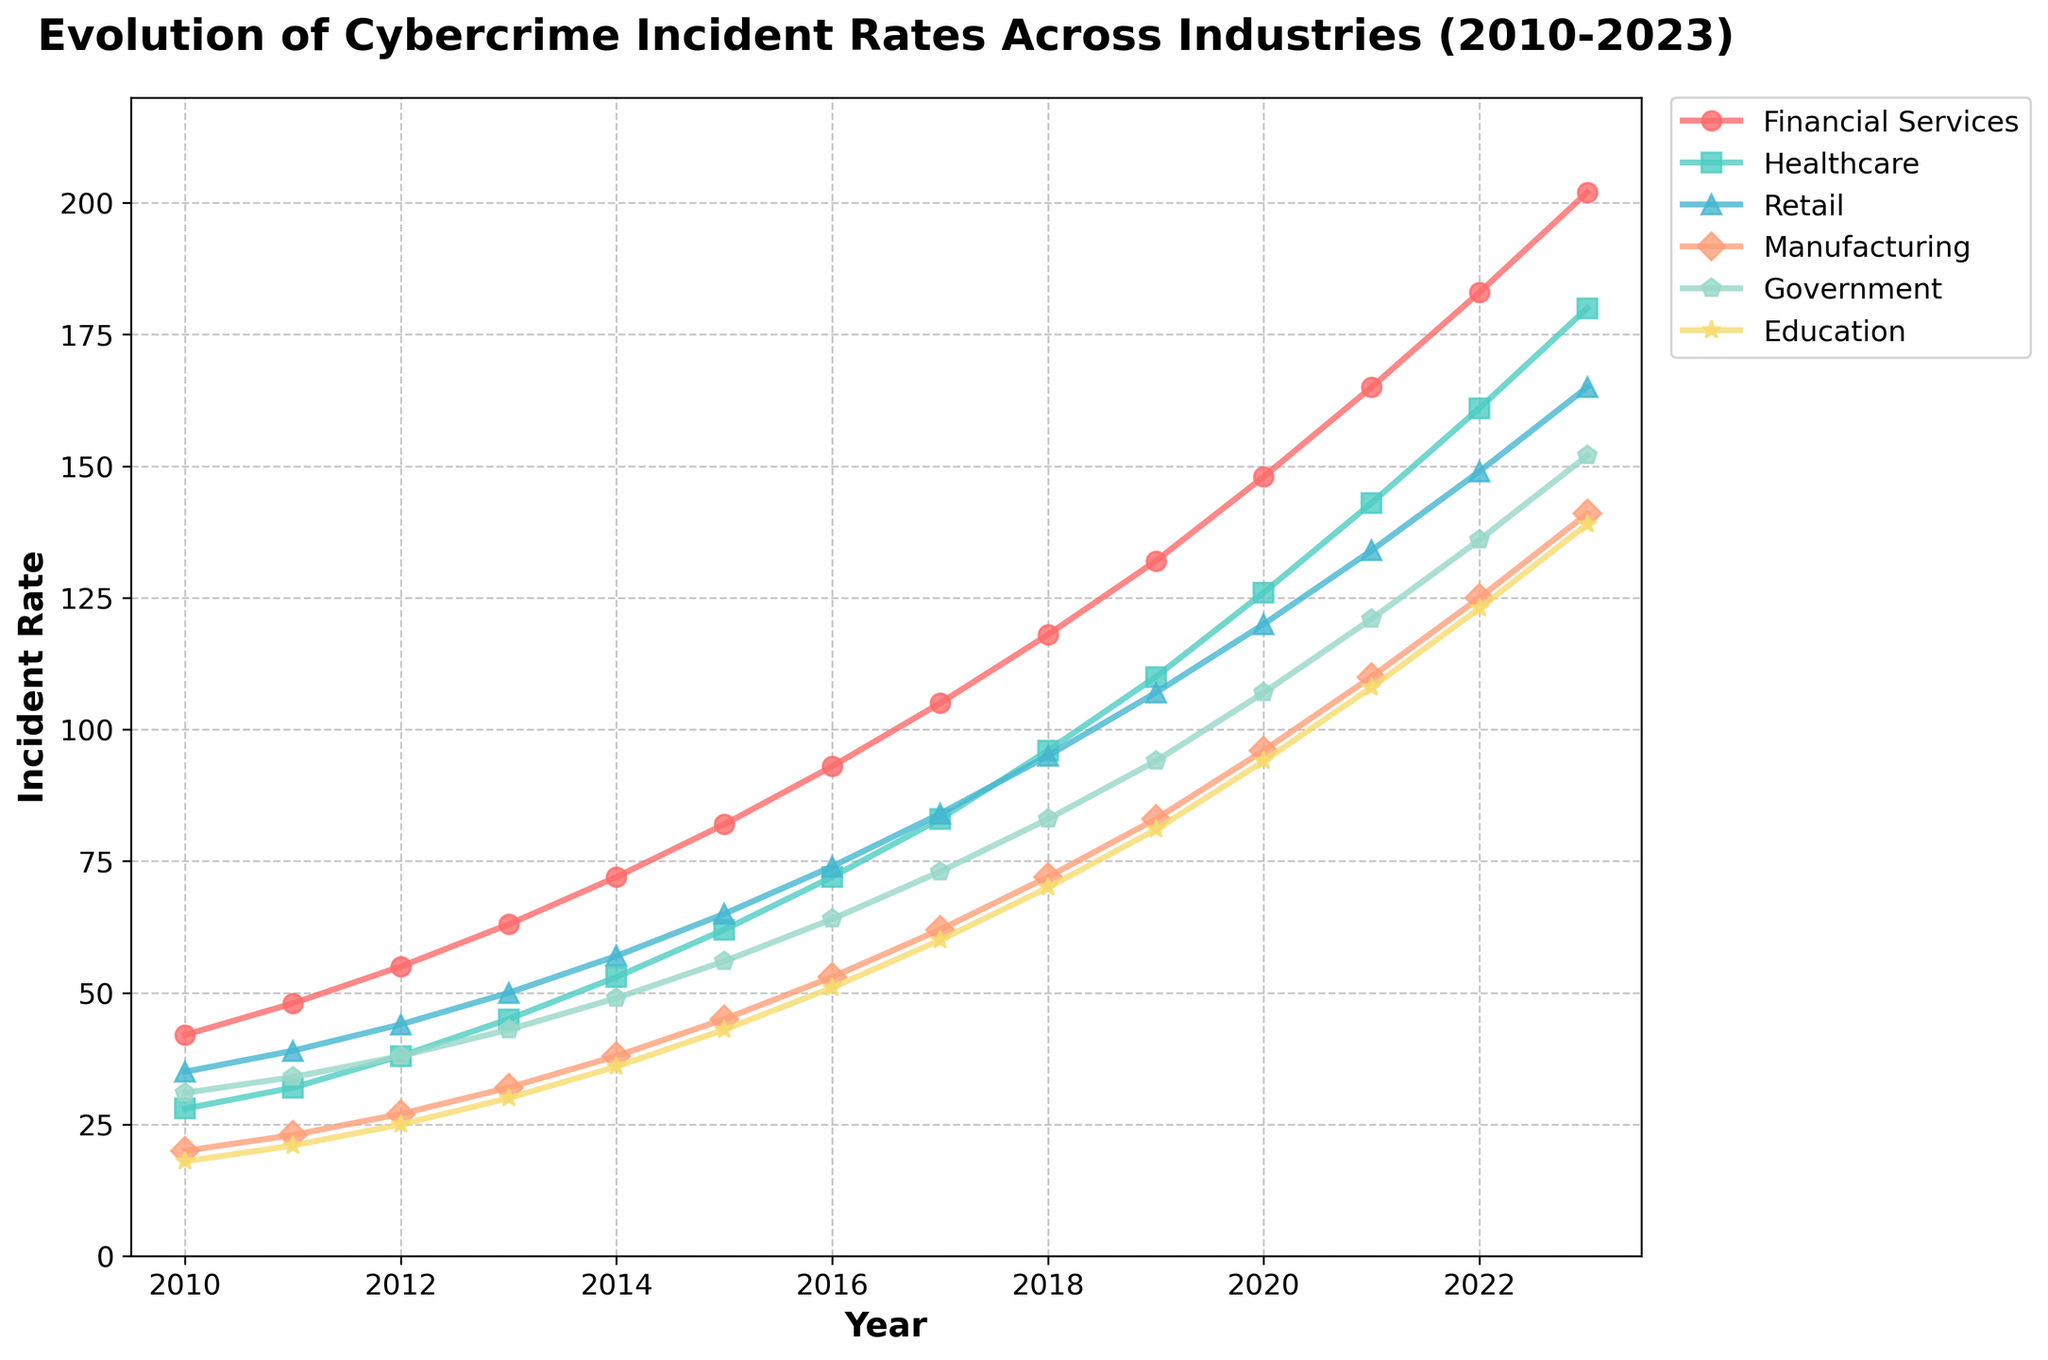What is the incident rate for the Financial Services industry in 2018? Find the point on the line for the Financial Services industry corresponding to the year 2018. The value is 118 according to the chart.
Answer: 118 Which industry had the highest incident rate in 2023? Compare the end points (2023) of all lines representing different industries. The Financial Services line is the highest at 202 incidents.
Answer: Financial Services Between which years did the Healthcare industry see the highest increase in incident rates? Examine the slope of the line for the Healthcare industry and identify the years with the steepest increase. From 2016 to 2017, it increased from 72 to 83, which is the highest yearly increase of 11.
Answer: 2016-2017 How did the incident rates for the Government sector change from 2011 to 2013? Look at the data points for the Government sector in 2011 and 2013, which are 34 and 43 respectively. The change is 43 - 34, an increase of 9.
Answer: Increased by 9 On average, what was the incident rate for the Retail industry from 2010 to 2023? Sum the incident rates for Retail across all years and divide by the number of years. Total is (35 + 39 + 44 + 50 + 57 + 65 + 74 + 84 + 95 + 107 + 120 + 134 + 149 + 165) = 1263. The number of years is 14, so the average is 1263 / 14.
Answer: 90.21 Which industry had a greater incident rate increase from 2010 to 2023: Education or Manufacturing? Calculate the differences for both industries. Education increased from 18 to 139, a change of 121. Manufacturing increased from 20 to 141, a change of 121.
Answer: Both increased equally What is the trend of the incident rates in the Healthcare industry from 2010 to 2023? Follow the line for Healthcare from 2010 to 2023. The incident rates show a continuous upward trend, starting at 28 in 2010 and reaching 180 in 2023.
Answer: Continuous upward trend In what year did the Retail industry surpass the Manufacturing industry in incident rates? Compare the data points year by year. Retail surpassed Manufacturing in 2014, with Retail at 57 and Manufacturing at 38.
Answer: 2014 